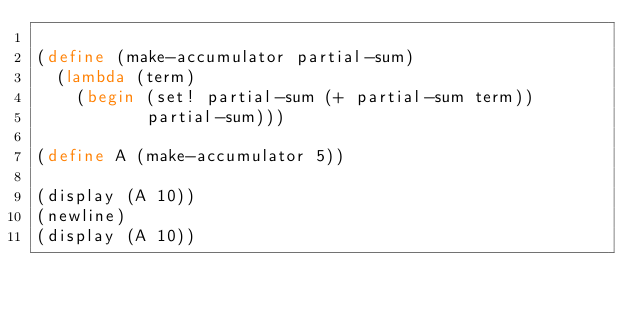Convert code to text. <code><loc_0><loc_0><loc_500><loc_500><_Scheme_>
(define (make-accumulator partial-sum)
  (lambda (term)
    (begin (set! partial-sum (+ partial-sum term))
           partial-sum)))

(define A (make-accumulator 5))

(display (A 10))
(newline)
(display (A 10))



</code> 